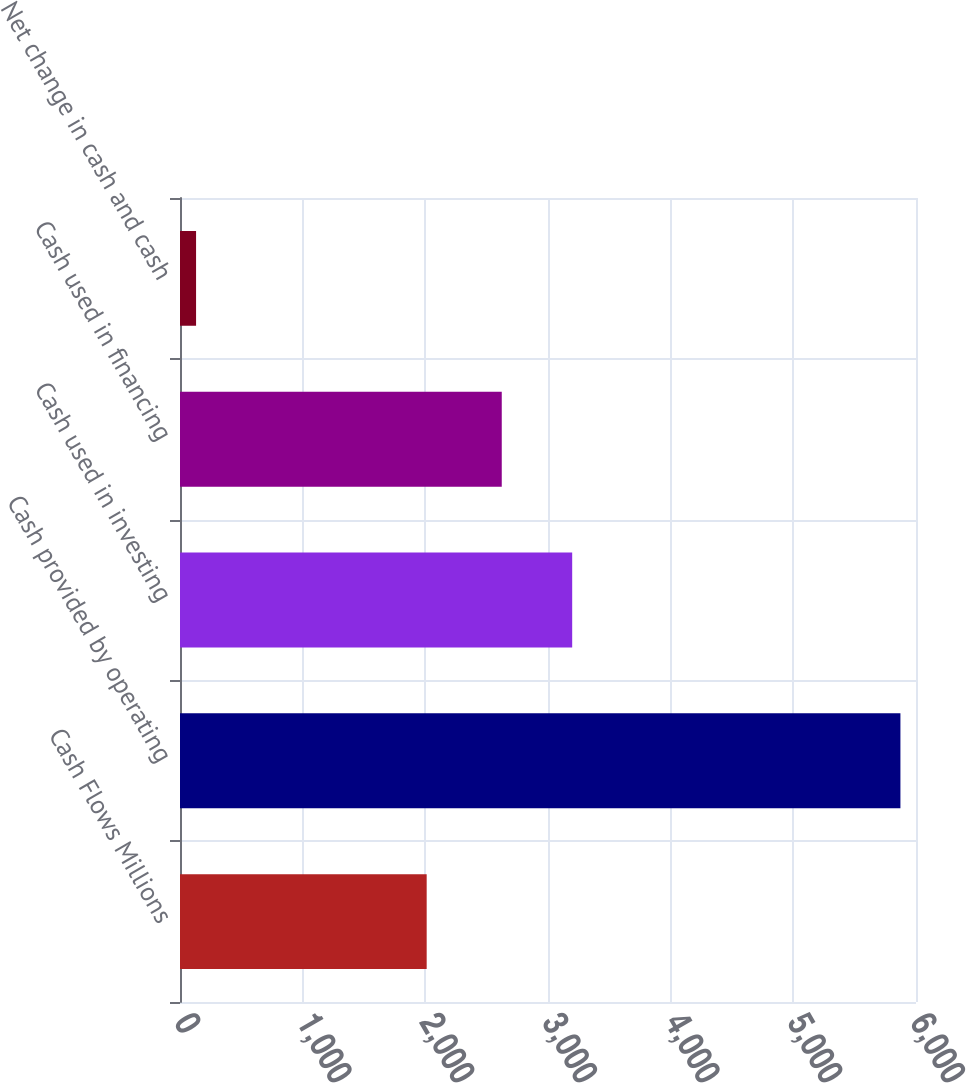<chart> <loc_0><loc_0><loc_500><loc_500><bar_chart><fcel>Cash Flows Millions<fcel>Cash provided by operating<fcel>Cash used in investing<fcel>Cash used in financing<fcel>Net change in cash and cash<nl><fcel>2011<fcel>5873<fcel>3197.2<fcel>2623<fcel>131<nl></chart> 